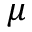<formula> <loc_0><loc_0><loc_500><loc_500>\mu</formula> 